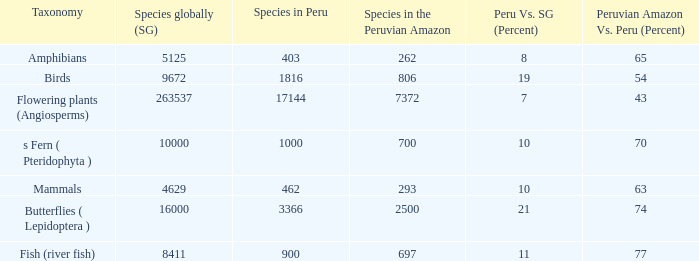What's the species in the world with peruvian amazon vs. peru (percent)  of 63 4629.0. 